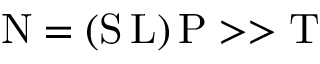<formula> <loc_0><loc_0><loc_500><loc_500>N = ( S \, L ) \, P > > T</formula> 